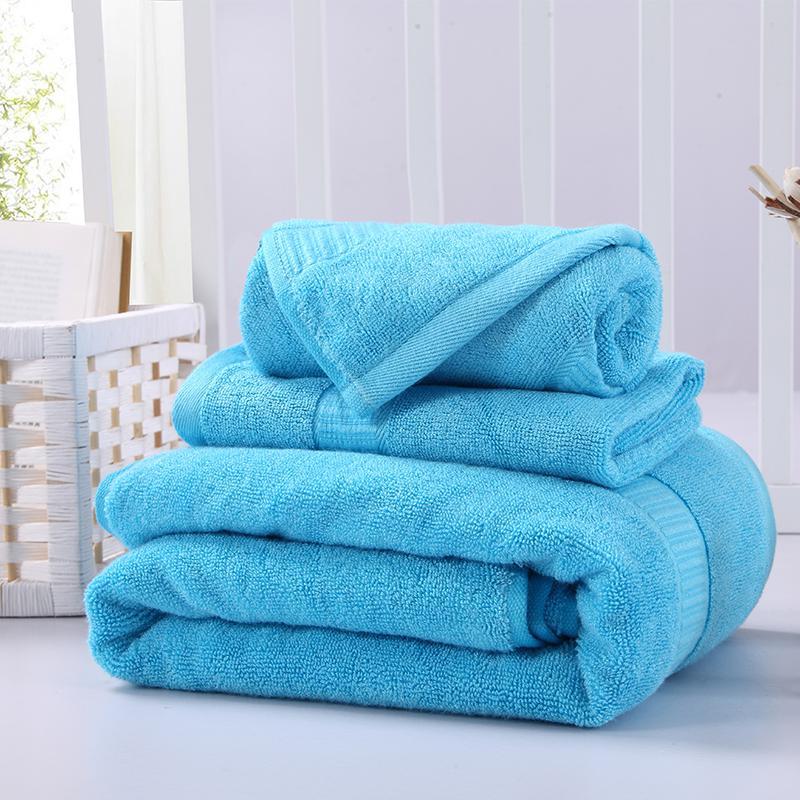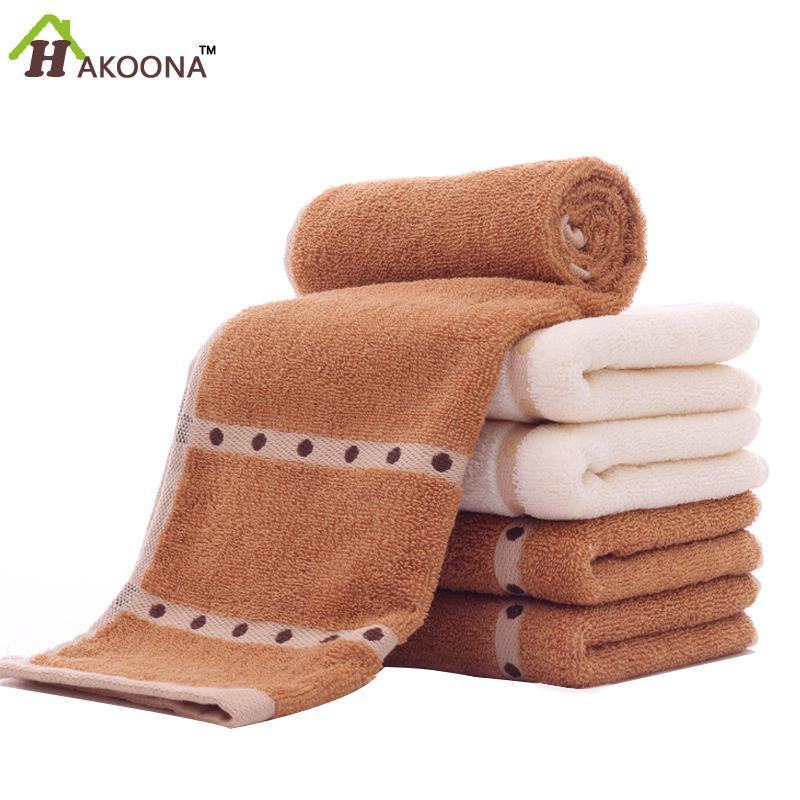The first image is the image on the left, the second image is the image on the right. Examine the images to the left and right. Is the description "There are three folded towels on the right image." accurate? Answer yes or no. No. 